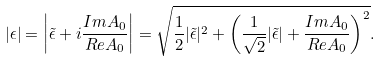Convert formula to latex. <formula><loc_0><loc_0><loc_500><loc_500>| \epsilon | = \left | \tilde { \epsilon } + i \frac { I m A _ { 0 } } { R e A _ { 0 } } \right | = \sqrt { \frac { 1 } { 2 } | \tilde { \epsilon } | ^ { 2 } + \left ( \frac { 1 } { \sqrt { 2 } } | \tilde { \epsilon } | + \frac { I m A _ { 0 } } { R e A _ { 0 } } \right ) ^ { 2 } } .</formula> 